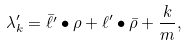Convert formula to latex. <formula><loc_0><loc_0><loc_500><loc_500>\lambda ^ { \prime } _ { k } = \bar { \ell ^ { \prime } } \bullet \rho + \ell ^ { \prime } \bullet \bar { \rho } + \frac { k } { m } ,</formula> 